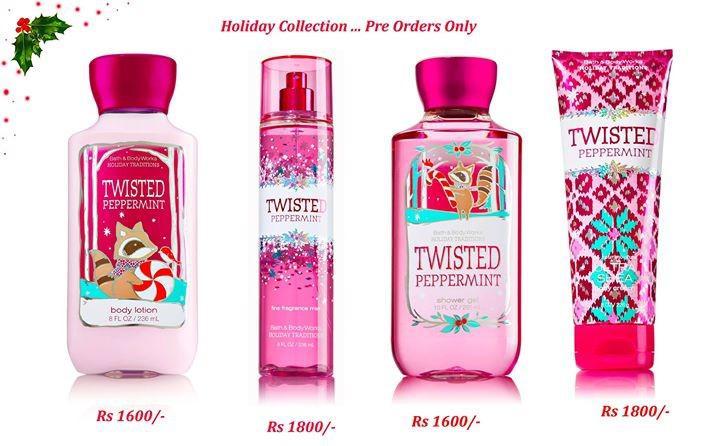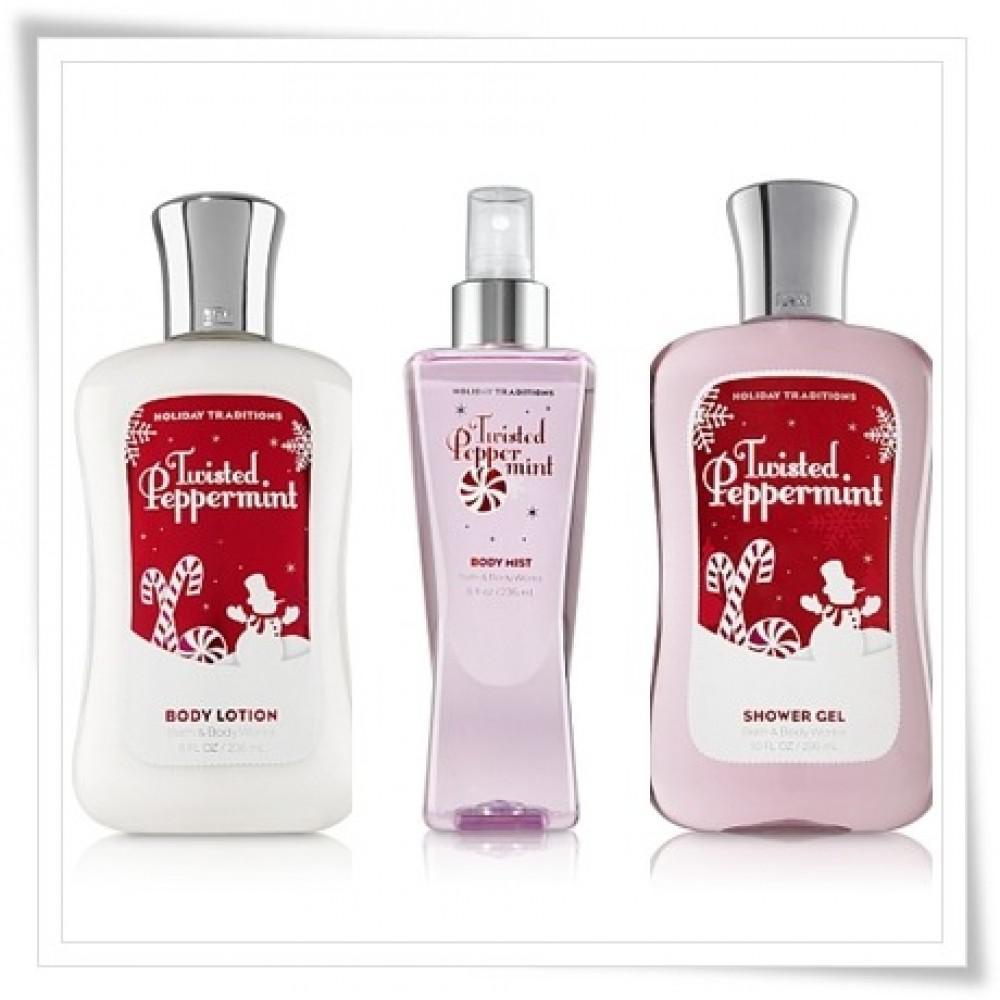The first image is the image on the left, the second image is the image on the right. For the images displayed, is the sentence "One of the images shows four or more products." factually correct? Answer yes or no. Yes. The first image is the image on the left, the second image is the image on the right. For the images displayed, is the sentence "An image with no more than four items includes exactly one product that stands on its cap." factually correct? Answer yes or no. Yes. 